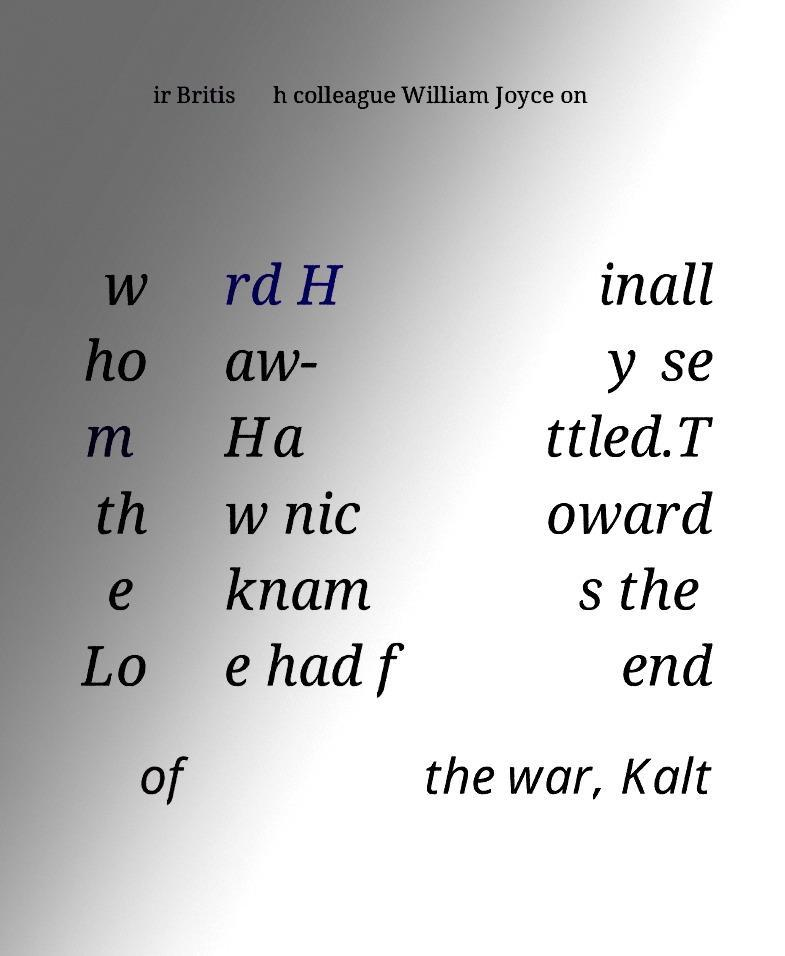Please identify and transcribe the text found in this image. ir Britis h colleague William Joyce on w ho m th e Lo rd H aw- Ha w nic knam e had f inall y se ttled.T oward s the end of the war, Kalt 